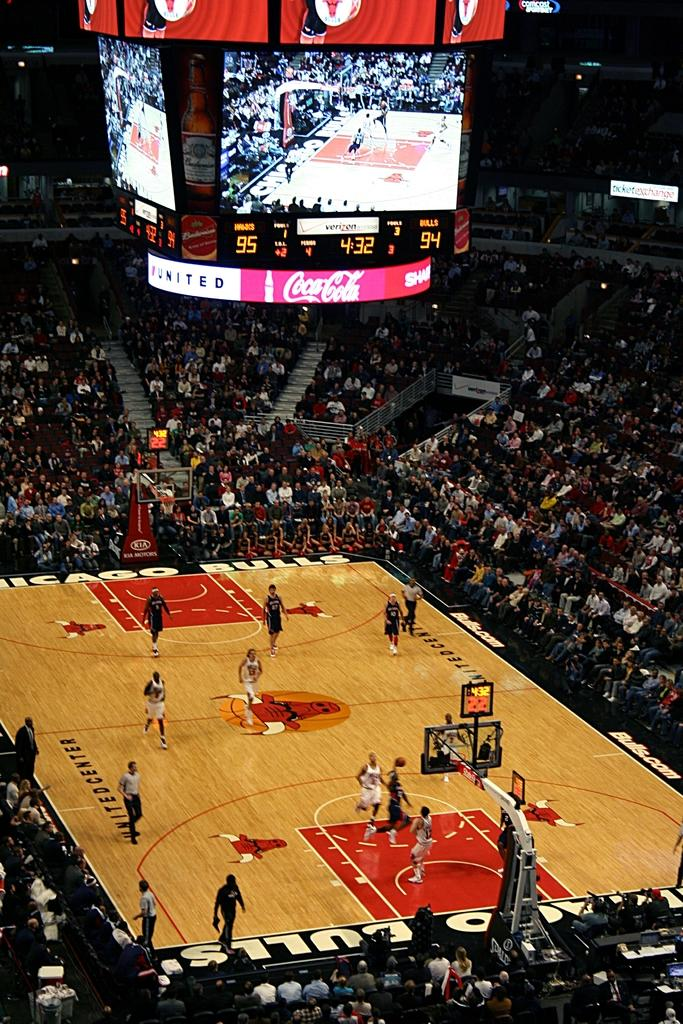Provide a one-sentence caption for the provided image. A packed basketball game is underway sponsored by Coca-Cola. 